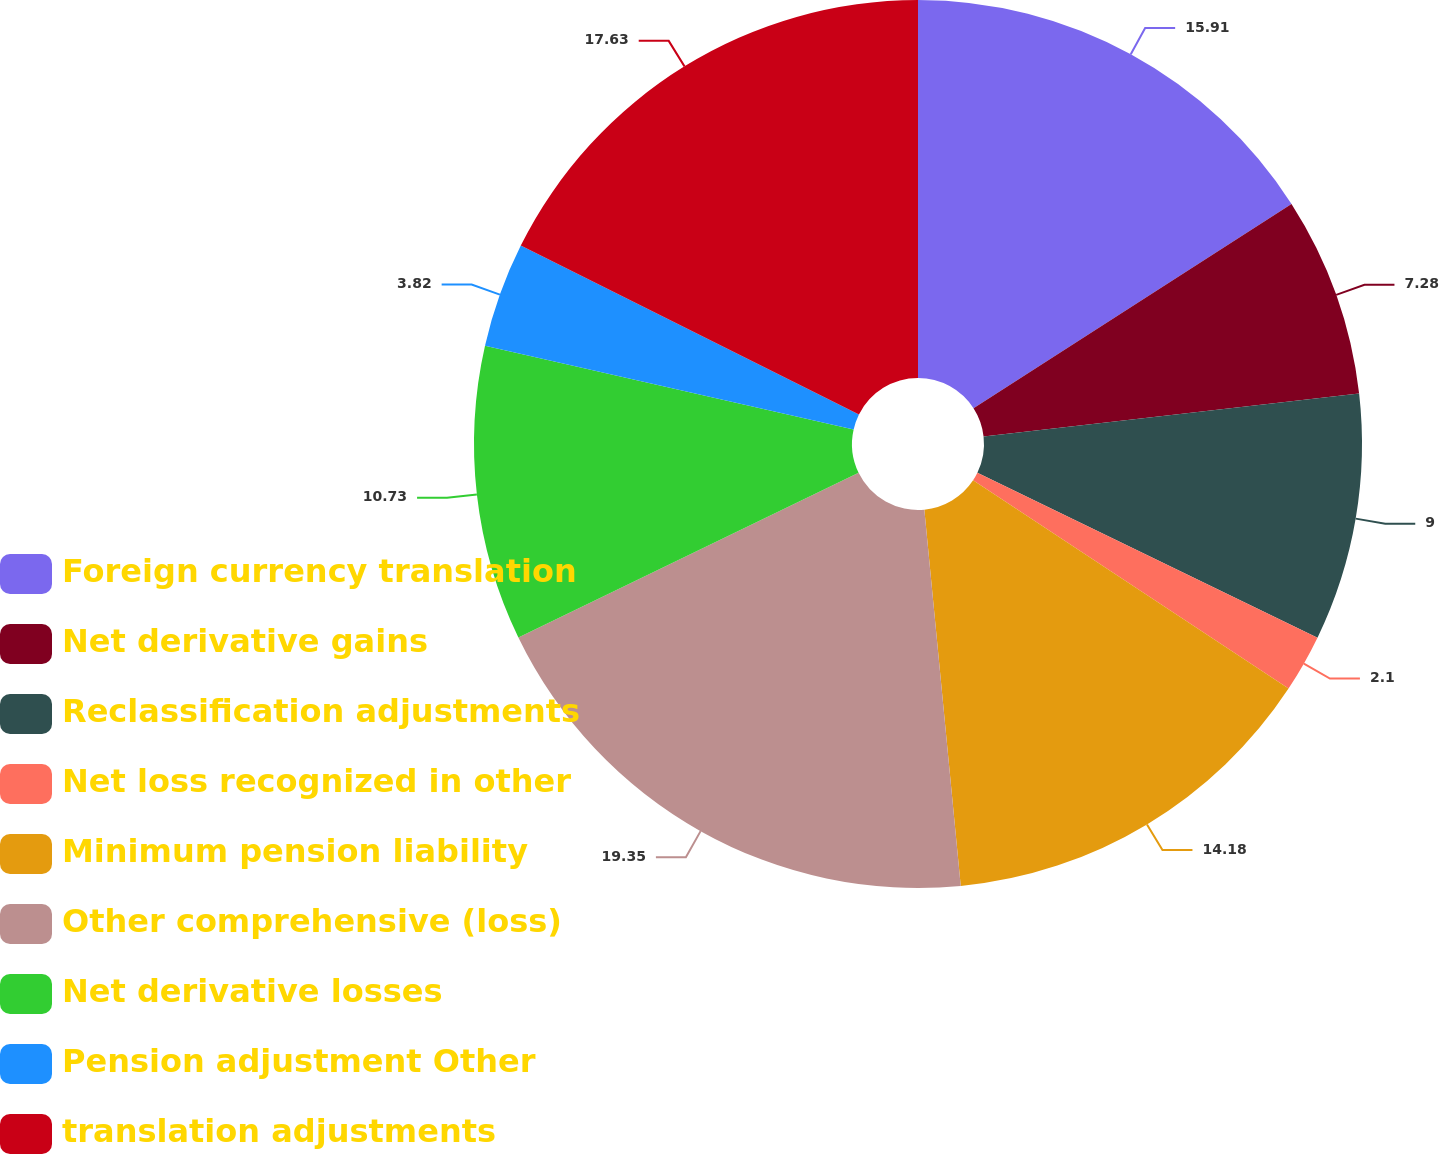Convert chart to OTSL. <chart><loc_0><loc_0><loc_500><loc_500><pie_chart><fcel>Foreign currency translation<fcel>Net derivative gains<fcel>Reclassification adjustments<fcel>Net loss recognized in other<fcel>Minimum pension liability<fcel>Other comprehensive (loss)<fcel>Net derivative losses<fcel>Pension adjustment Other<fcel>translation adjustments<nl><fcel>15.91%<fcel>7.28%<fcel>9.0%<fcel>2.1%<fcel>14.18%<fcel>19.36%<fcel>10.73%<fcel>3.82%<fcel>17.63%<nl></chart> 